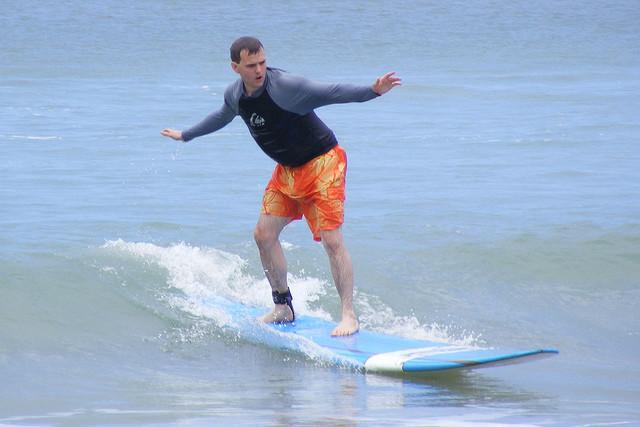What is the man doing?
Keep it brief. Surfing. What color is the board?
Be succinct. Blue. Is there a body of water in this photo?
Short answer required. Yes. 